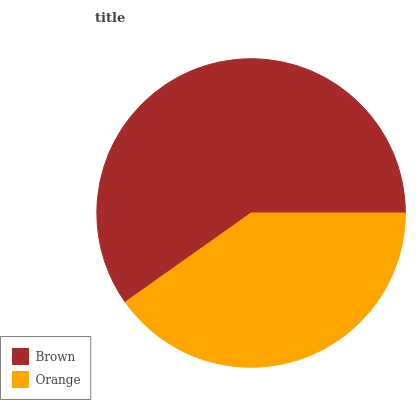Is Orange the minimum?
Answer yes or no. Yes. Is Brown the maximum?
Answer yes or no. Yes. Is Orange the maximum?
Answer yes or no. No. Is Brown greater than Orange?
Answer yes or no. Yes. Is Orange less than Brown?
Answer yes or no. Yes. Is Orange greater than Brown?
Answer yes or no. No. Is Brown less than Orange?
Answer yes or no. No. Is Brown the high median?
Answer yes or no. Yes. Is Orange the low median?
Answer yes or no. Yes. Is Orange the high median?
Answer yes or no. No. Is Brown the low median?
Answer yes or no. No. 